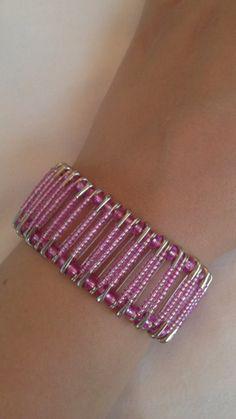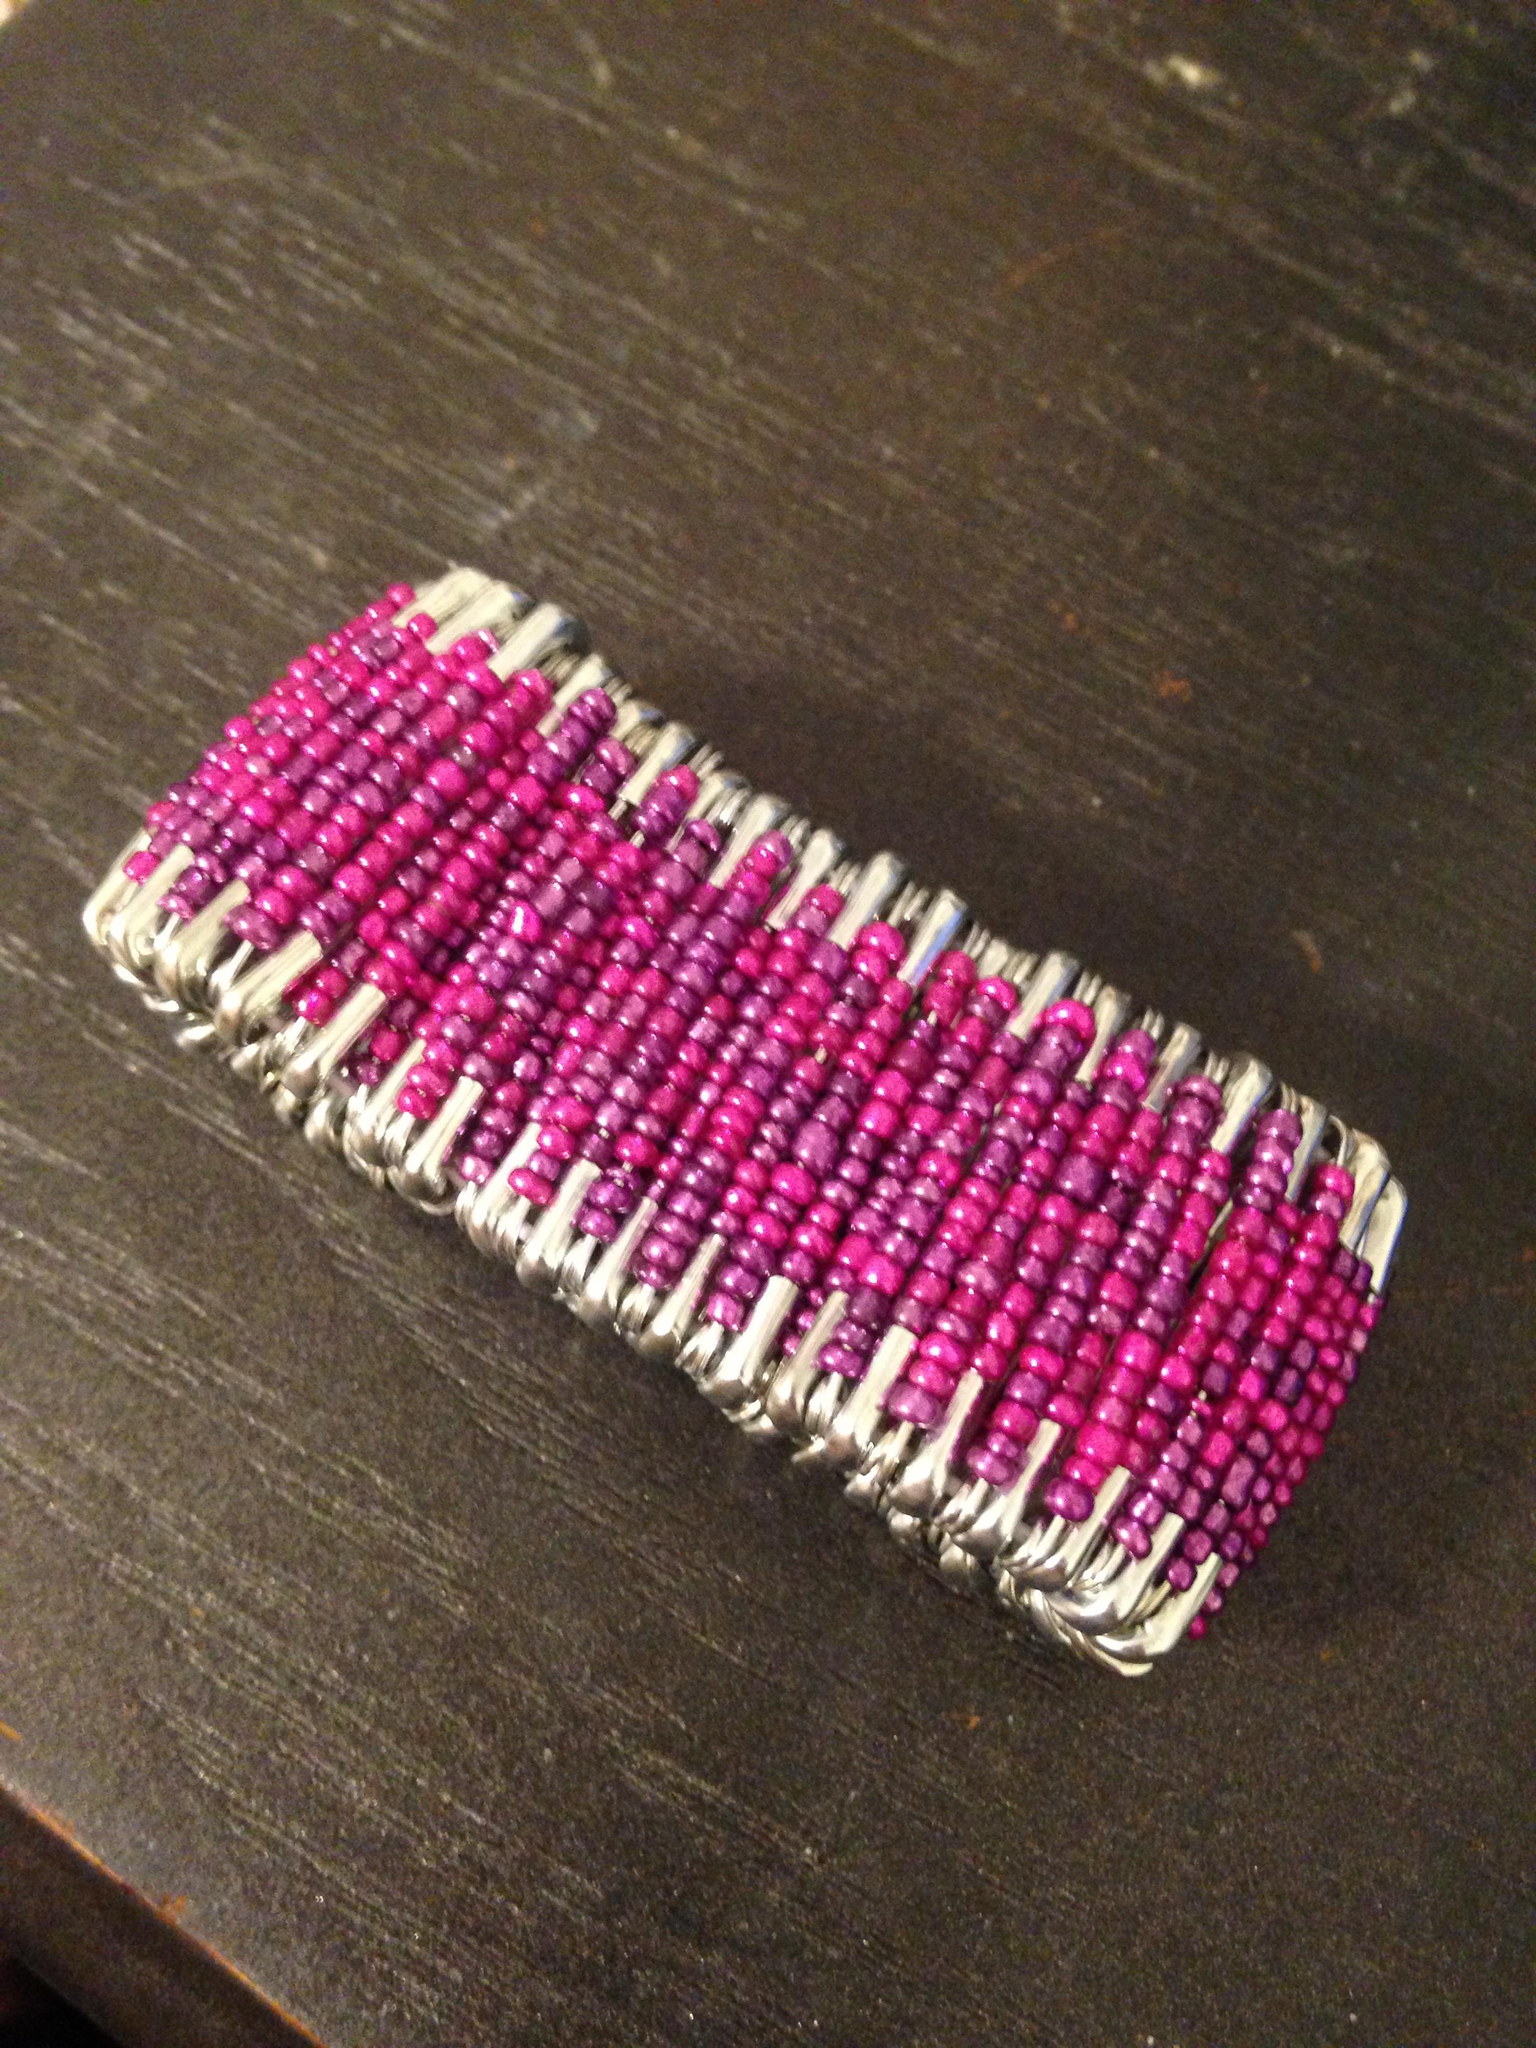The first image is the image on the left, the second image is the image on the right. Given the left and right images, does the statement "A bracelet has at least three different colored beads." hold true? Answer yes or no. No. 